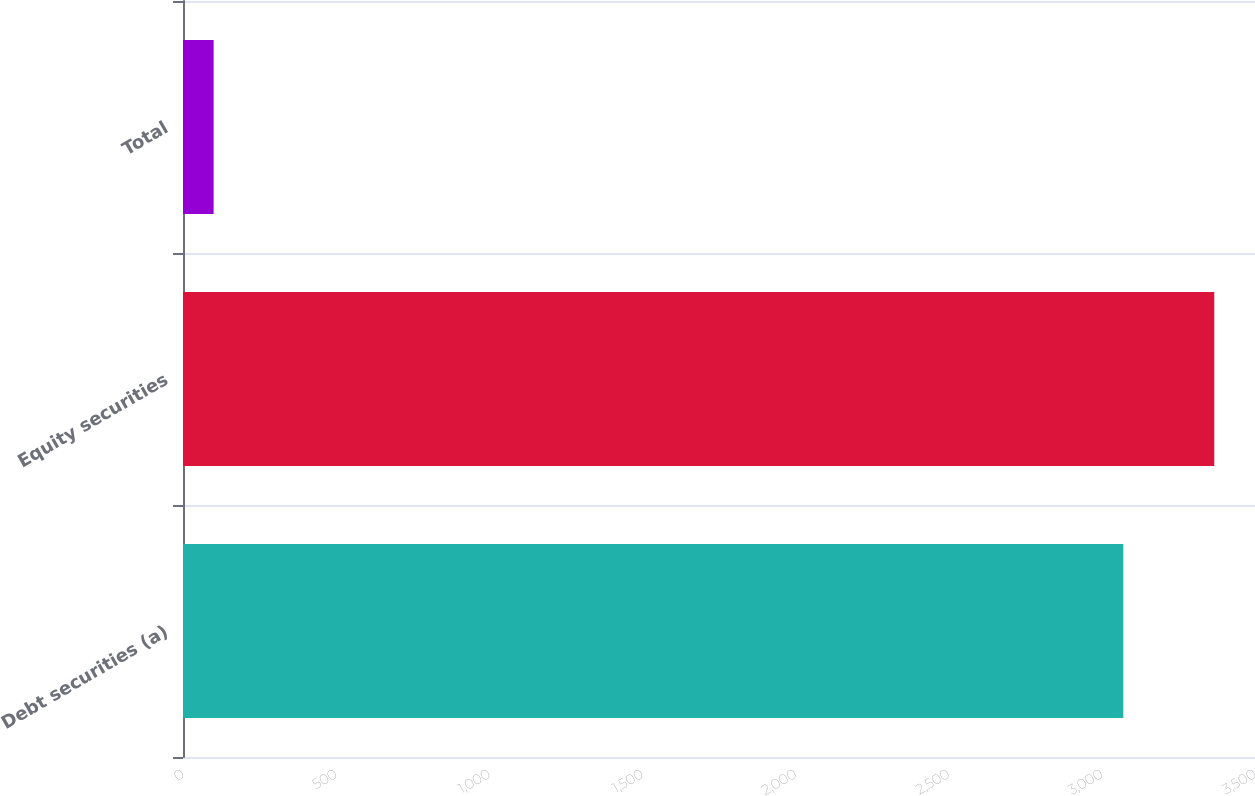Convert chart to OTSL. <chart><loc_0><loc_0><loc_500><loc_500><bar_chart><fcel>Debt securities (a)<fcel>Equity securities<fcel>Total<nl><fcel>3070<fcel>3367<fcel>100<nl></chart> 